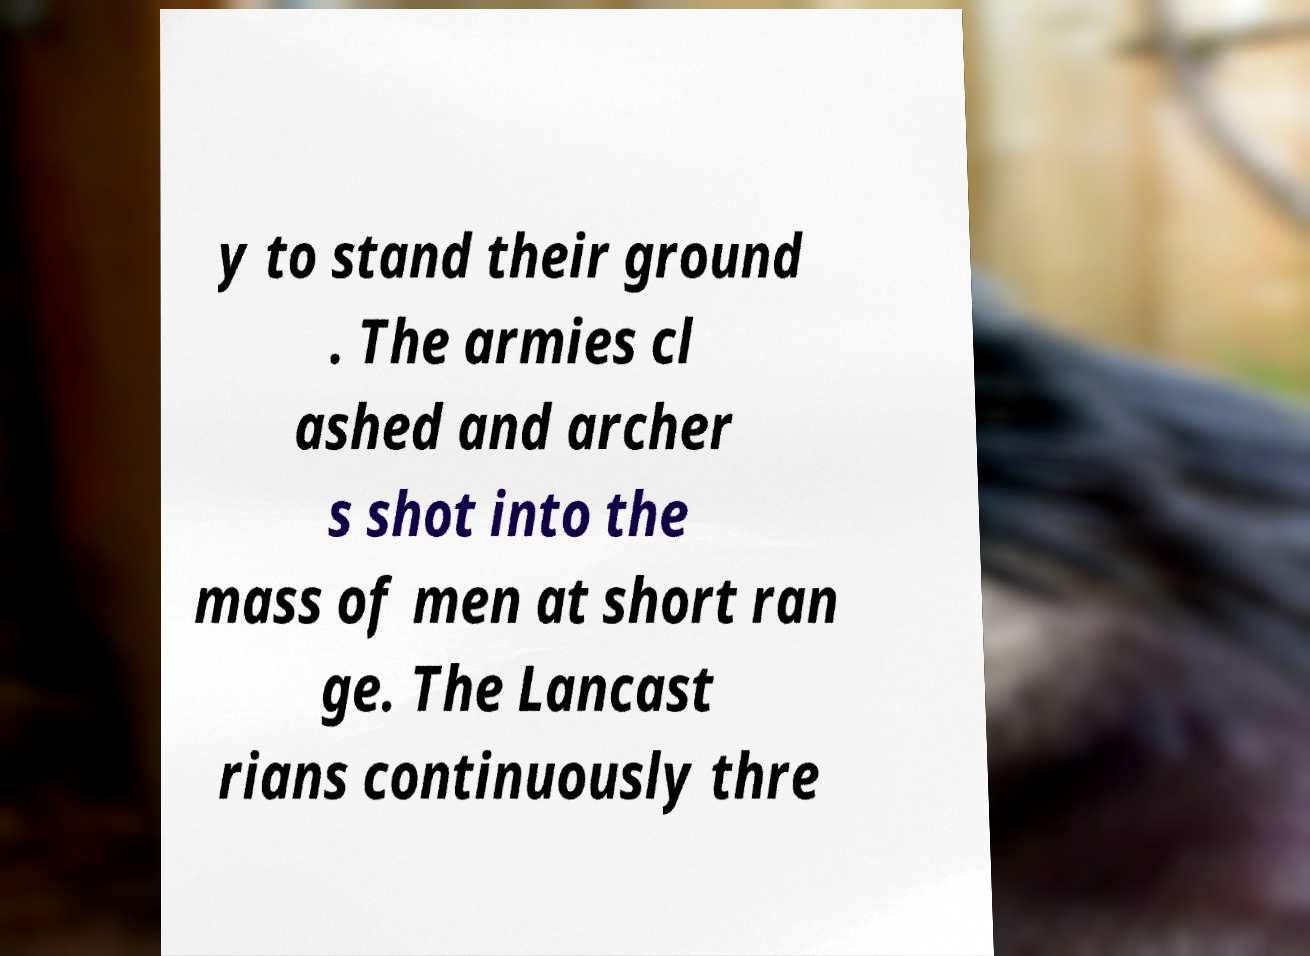Please identify and transcribe the text found in this image. y to stand their ground . The armies cl ashed and archer s shot into the mass of men at short ran ge. The Lancast rians continuously thre 